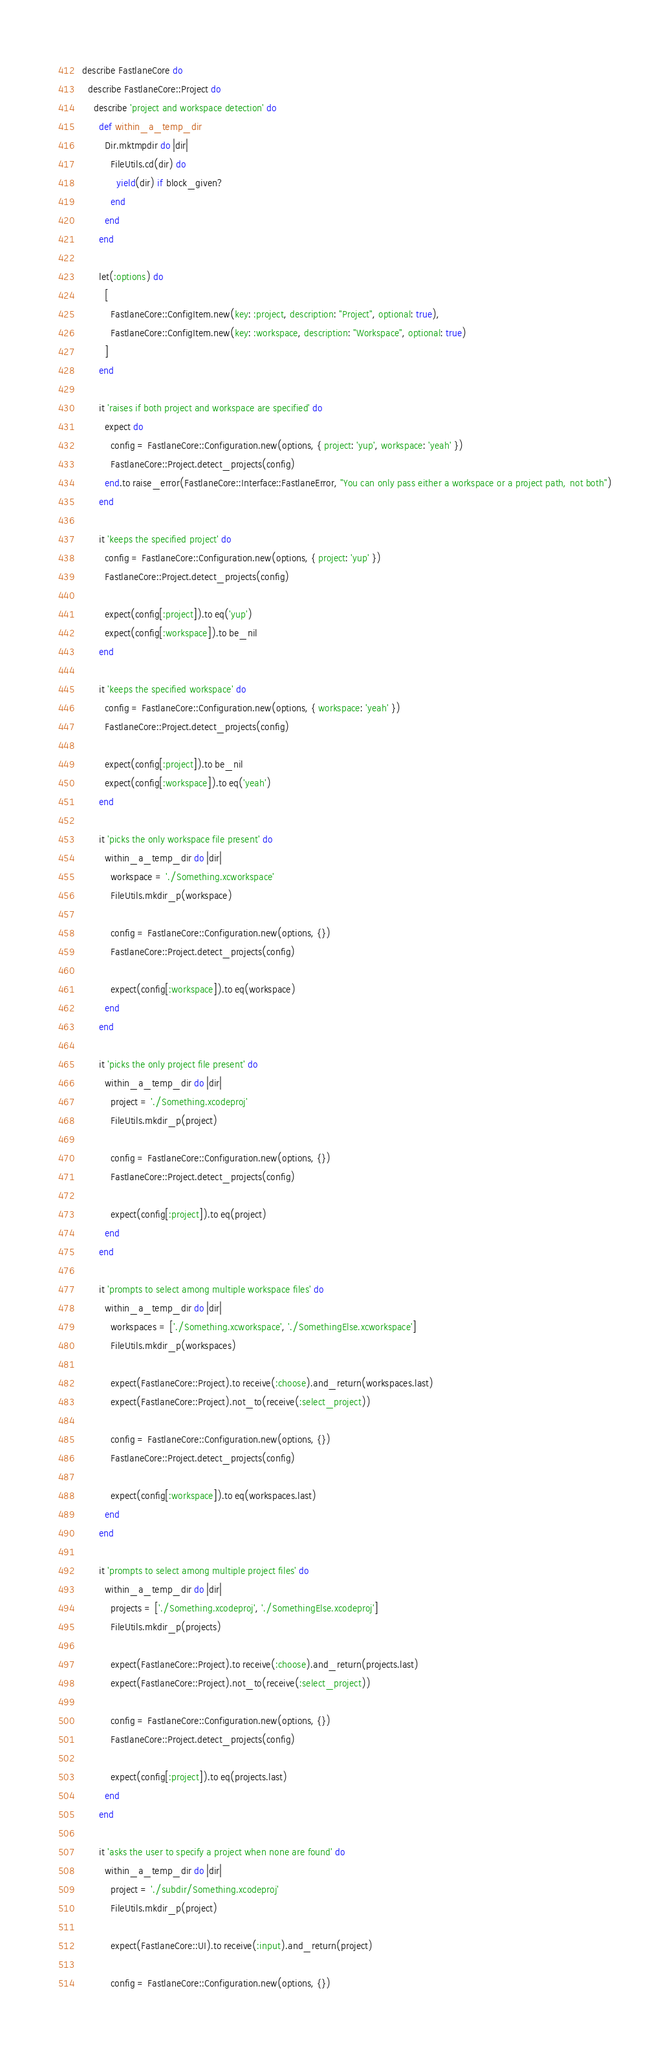<code> <loc_0><loc_0><loc_500><loc_500><_Ruby_>describe FastlaneCore do
  describe FastlaneCore::Project do
    describe 'project and workspace detection' do
      def within_a_temp_dir
        Dir.mktmpdir do |dir|
          FileUtils.cd(dir) do
            yield(dir) if block_given?
          end
        end
      end

      let(:options) do
        [
          FastlaneCore::ConfigItem.new(key: :project, description: "Project", optional: true),
          FastlaneCore::ConfigItem.new(key: :workspace, description: "Workspace", optional: true)
        ]
      end

      it 'raises if both project and workspace are specified' do
        expect do
          config = FastlaneCore::Configuration.new(options, { project: 'yup', workspace: 'yeah' })
          FastlaneCore::Project.detect_projects(config)
        end.to raise_error(FastlaneCore::Interface::FastlaneError, "You can only pass either a workspace or a project path, not both")
      end

      it 'keeps the specified project' do
        config = FastlaneCore::Configuration.new(options, { project: 'yup' })
        FastlaneCore::Project.detect_projects(config)

        expect(config[:project]).to eq('yup')
        expect(config[:workspace]).to be_nil
      end

      it 'keeps the specified workspace' do
        config = FastlaneCore::Configuration.new(options, { workspace: 'yeah' })
        FastlaneCore::Project.detect_projects(config)

        expect(config[:project]).to be_nil
        expect(config[:workspace]).to eq('yeah')
      end

      it 'picks the only workspace file present' do
        within_a_temp_dir do |dir|
          workspace = './Something.xcworkspace'
          FileUtils.mkdir_p(workspace)

          config = FastlaneCore::Configuration.new(options, {})
          FastlaneCore::Project.detect_projects(config)

          expect(config[:workspace]).to eq(workspace)
        end
      end

      it 'picks the only project file present' do
        within_a_temp_dir do |dir|
          project = './Something.xcodeproj'
          FileUtils.mkdir_p(project)

          config = FastlaneCore::Configuration.new(options, {})
          FastlaneCore::Project.detect_projects(config)

          expect(config[:project]).to eq(project)
        end
      end

      it 'prompts to select among multiple workspace files' do
        within_a_temp_dir do |dir|
          workspaces = ['./Something.xcworkspace', './SomethingElse.xcworkspace']
          FileUtils.mkdir_p(workspaces)

          expect(FastlaneCore::Project).to receive(:choose).and_return(workspaces.last)
          expect(FastlaneCore::Project).not_to(receive(:select_project))

          config = FastlaneCore::Configuration.new(options, {})
          FastlaneCore::Project.detect_projects(config)

          expect(config[:workspace]).to eq(workspaces.last)
        end
      end

      it 'prompts to select among multiple project files' do
        within_a_temp_dir do |dir|
          projects = ['./Something.xcodeproj', './SomethingElse.xcodeproj']
          FileUtils.mkdir_p(projects)

          expect(FastlaneCore::Project).to receive(:choose).and_return(projects.last)
          expect(FastlaneCore::Project).not_to(receive(:select_project))

          config = FastlaneCore::Configuration.new(options, {})
          FastlaneCore::Project.detect_projects(config)

          expect(config[:project]).to eq(projects.last)
        end
      end

      it 'asks the user to specify a project when none are found' do
        within_a_temp_dir do |dir|
          project = './subdir/Something.xcodeproj'
          FileUtils.mkdir_p(project)

          expect(FastlaneCore::UI).to receive(:input).and_return(project)

          config = FastlaneCore::Configuration.new(options, {})</code> 